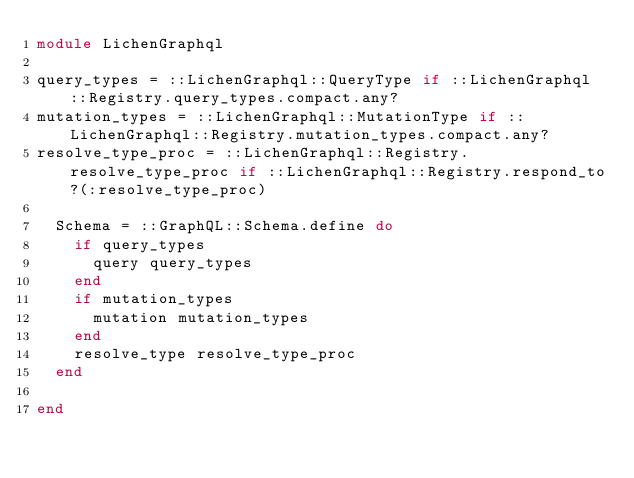<code> <loc_0><loc_0><loc_500><loc_500><_Ruby_>module LichenGraphql

query_types = ::LichenGraphql::QueryType if ::LichenGraphql::Registry.query_types.compact.any?
mutation_types = ::LichenGraphql::MutationType if ::LichenGraphql::Registry.mutation_types.compact.any?
resolve_type_proc = ::LichenGraphql::Registry.resolve_type_proc if ::LichenGraphql::Registry.respond_to?(:resolve_type_proc)

  Schema = ::GraphQL::Schema.define do
    if query_types
      query query_types
    end
    if mutation_types
      mutation mutation_types
    end
    resolve_type resolve_type_proc
  end

end
</code> 